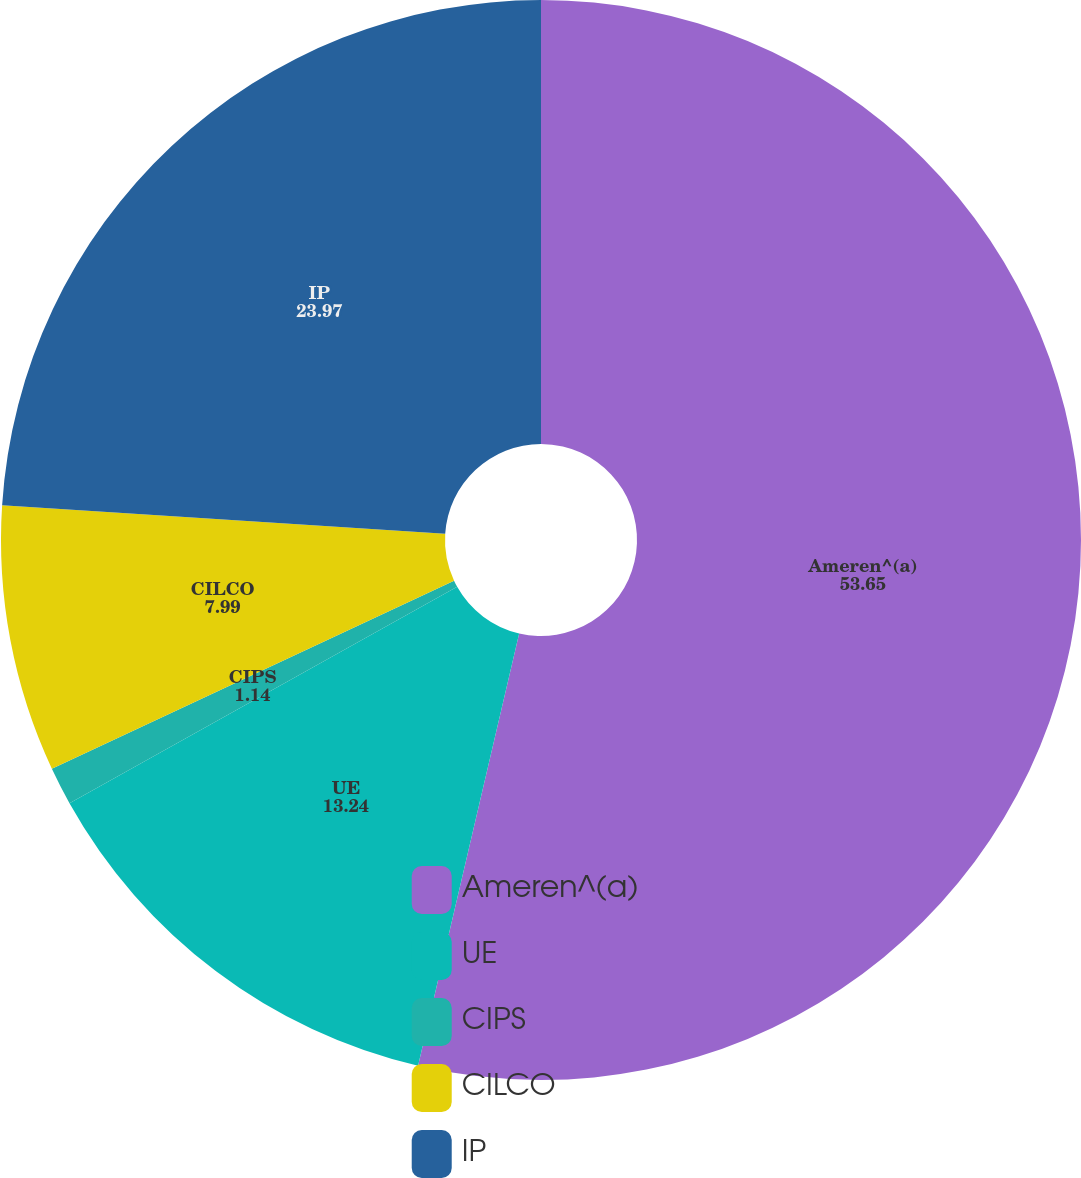Convert chart. <chart><loc_0><loc_0><loc_500><loc_500><pie_chart><fcel>Ameren^(a)<fcel>UE<fcel>CIPS<fcel>CILCO<fcel>IP<nl><fcel>53.65%<fcel>13.24%<fcel>1.14%<fcel>7.99%<fcel>23.97%<nl></chart> 